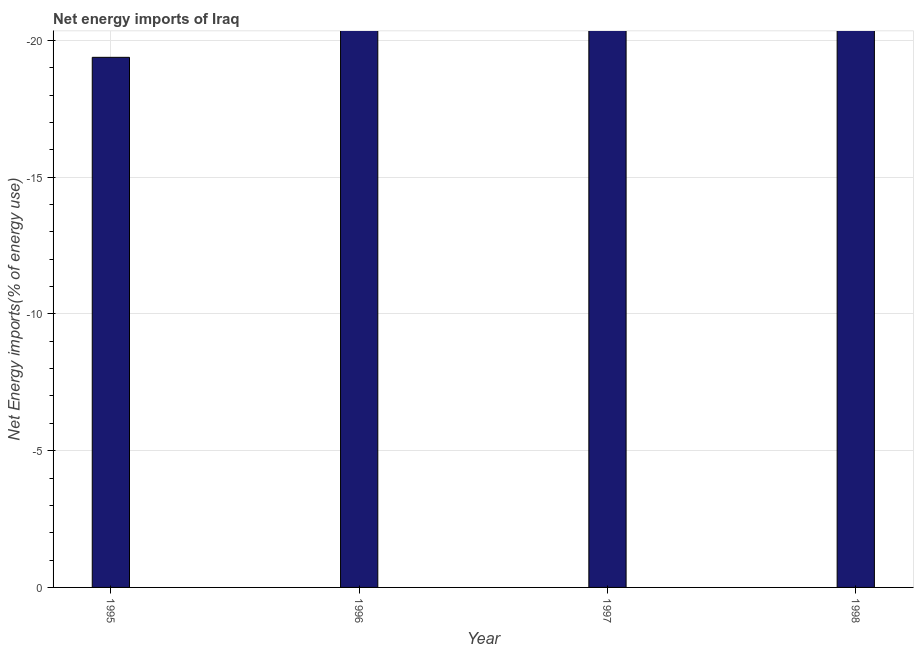Does the graph contain grids?
Your answer should be very brief. Yes. What is the title of the graph?
Your response must be concise. Net energy imports of Iraq. What is the label or title of the X-axis?
Give a very brief answer. Year. What is the label or title of the Y-axis?
Your answer should be compact. Net Energy imports(% of energy use). Across all years, what is the minimum energy imports?
Your answer should be compact. 0. What is the sum of the energy imports?
Ensure brevity in your answer.  0. What is the average energy imports per year?
Make the answer very short. 0. What is the median energy imports?
Give a very brief answer. 0. How many bars are there?
Give a very brief answer. 0. Are all the bars in the graph horizontal?
Provide a succinct answer. No. Are the values on the major ticks of Y-axis written in scientific E-notation?
Make the answer very short. No. What is the Net Energy imports(% of energy use) in 1996?
Your answer should be very brief. 0. What is the Net Energy imports(% of energy use) in 1998?
Make the answer very short. 0. 